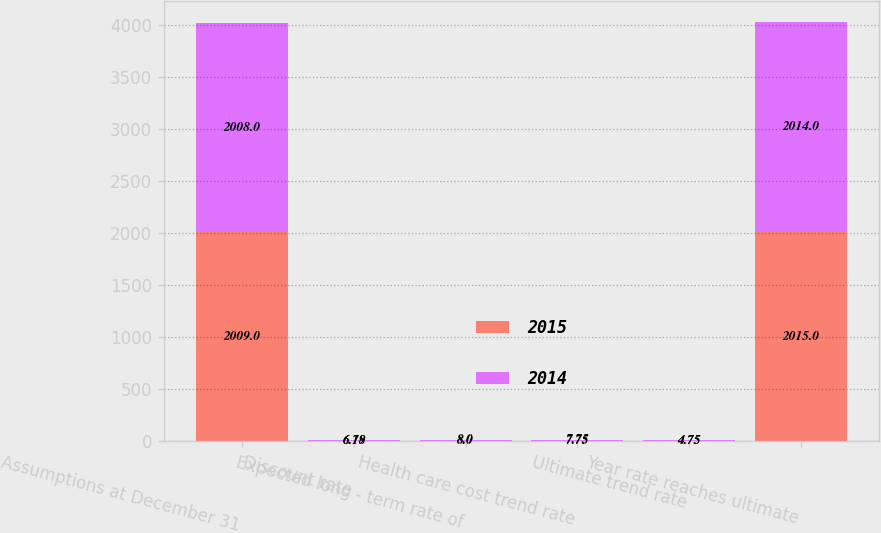<chart> <loc_0><loc_0><loc_500><loc_500><stacked_bar_chart><ecel><fcel>Assumptions at December 31<fcel>Discount rate<fcel>Expected long - term rate of<fcel>Health care cost trend rate<fcel>Ultimate trend rate<fcel>Year rate reaches ultimate<nl><fcel>2015<fcel>2009<fcel>6.18<fcel>8<fcel>7.75<fcel>4.75<fcel>2015<nl><fcel>2014<fcel>2008<fcel>6.79<fcel>8<fcel>7.75<fcel>4.75<fcel>2014<nl></chart> 